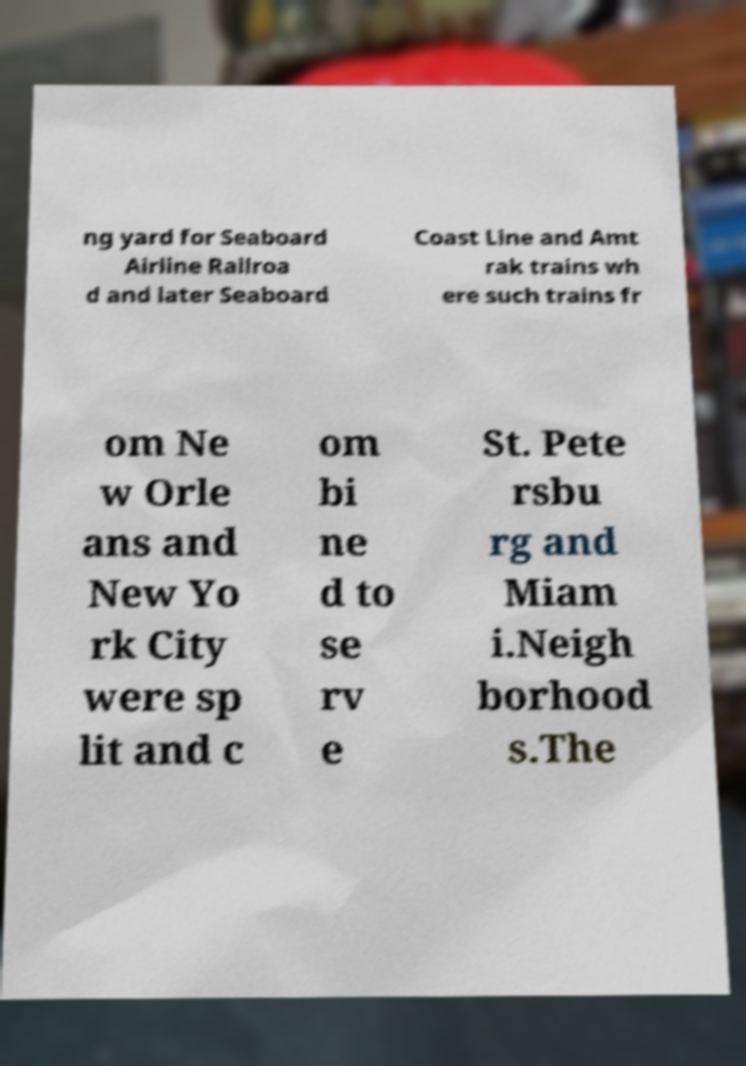I need the written content from this picture converted into text. Can you do that? ng yard for Seaboard Airline Railroa d and later Seaboard Coast Line and Amt rak trains wh ere such trains fr om Ne w Orle ans and New Yo rk City were sp lit and c om bi ne d to se rv e St. Pete rsbu rg and Miam i.Neigh borhood s.The 